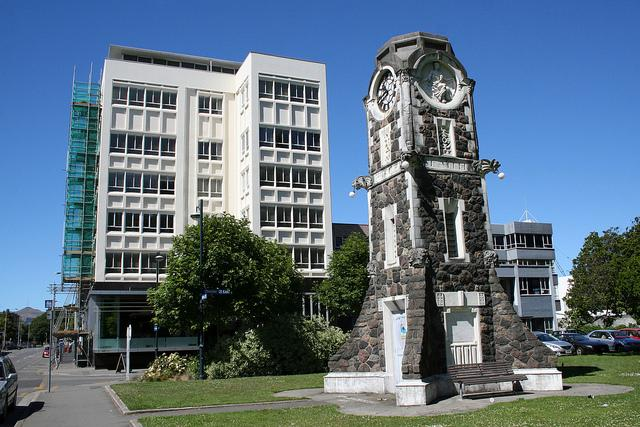How do you know there is work being done on the white building? scaffolding 